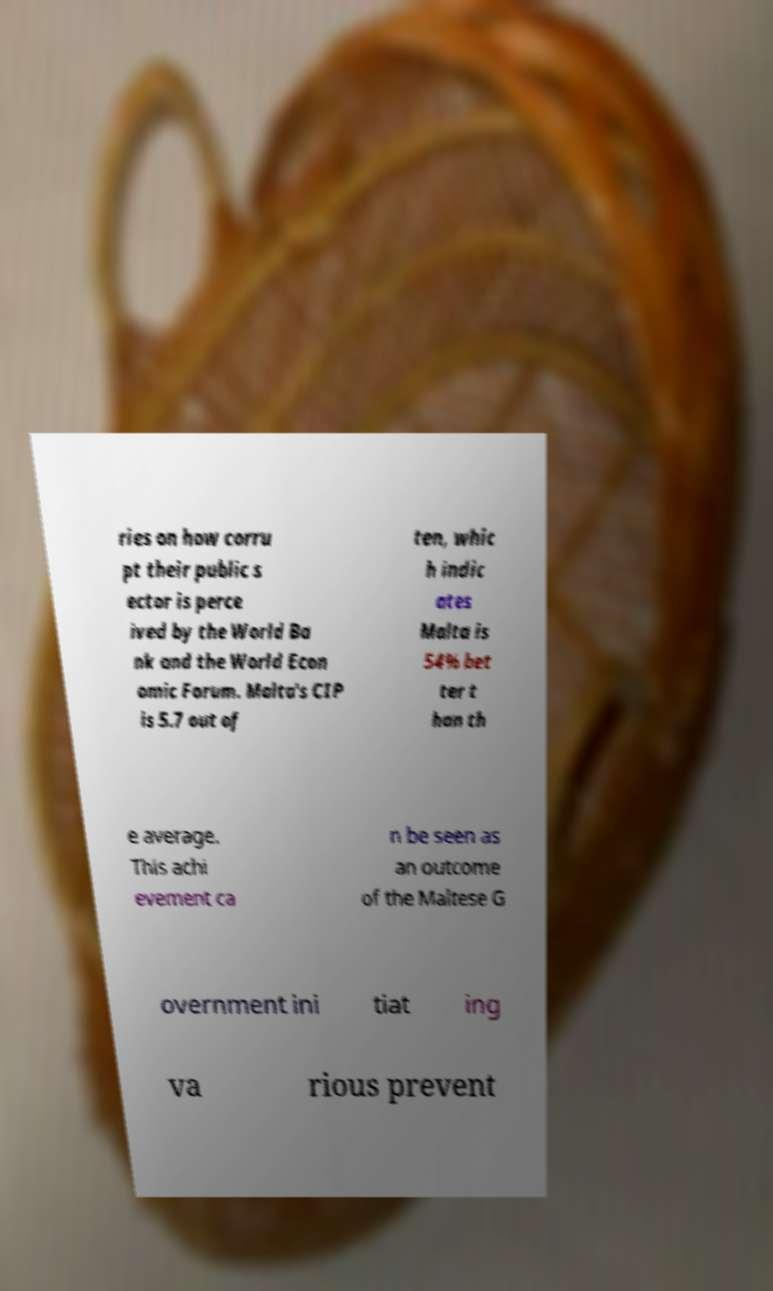Could you assist in decoding the text presented in this image and type it out clearly? ries on how corru pt their public s ector is perce ived by the World Ba nk and the World Econ omic Forum. Malta's CIP is 5.7 out of ten, whic h indic ates Malta is 54% bet ter t han th e average. This achi evement ca n be seen as an outcome of the Maltese G overnment ini tiat ing va rious prevent 